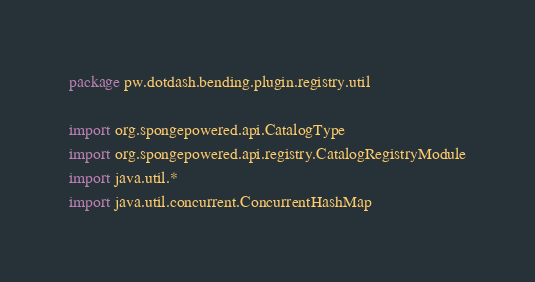Convert code to text. <code><loc_0><loc_0><loc_500><loc_500><_Kotlin_>package pw.dotdash.bending.plugin.registry.util

import org.spongepowered.api.CatalogType
import org.spongepowered.api.registry.CatalogRegistryModule
import java.util.*
import java.util.concurrent.ConcurrentHashMap
</code> 